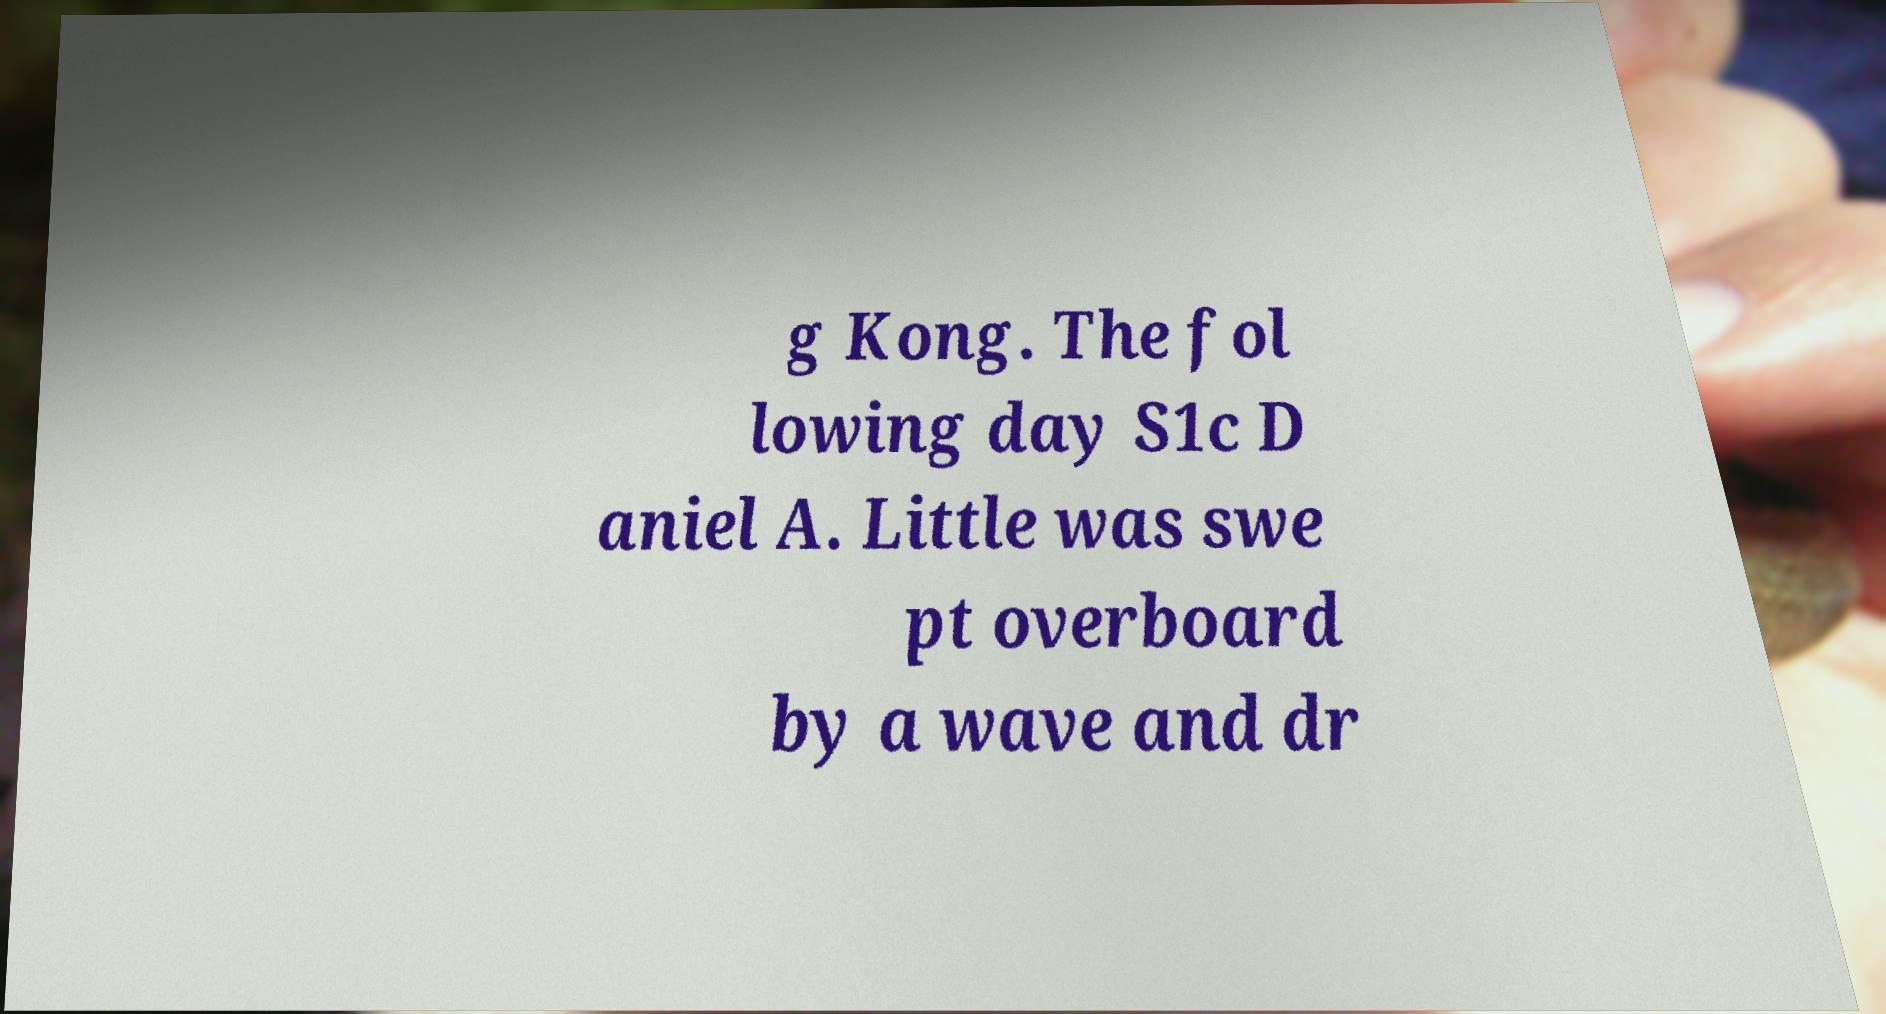I need the written content from this picture converted into text. Can you do that? g Kong. The fol lowing day S1c D aniel A. Little was swe pt overboard by a wave and dr 